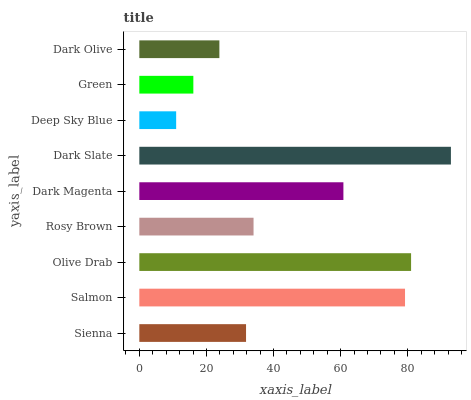Is Deep Sky Blue the minimum?
Answer yes or no. Yes. Is Dark Slate the maximum?
Answer yes or no. Yes. Is Salmon the minimum?
Answer yes or no. No. Is Salmon the maximum?
Answer yes or no. No. Is Salmon greater than Sienna?
Answer yes or no. Yes. Is Sienna less than Salmon?
Answer yes or no. Yes. Is Sienna greater than Salmon?
Answer yes or no. No. Is Salmon less than Sienna?
Answer yes or no. No. Is Rosy Brown the high median?
Answer yes or no. Yes. Is Rosy Brown the low median?
Answer yes or no. Yes. Is Deep Sky Blue the high median?
Answer yes or no. No. Is Salmon the low median?
Answer yes or no. No. 